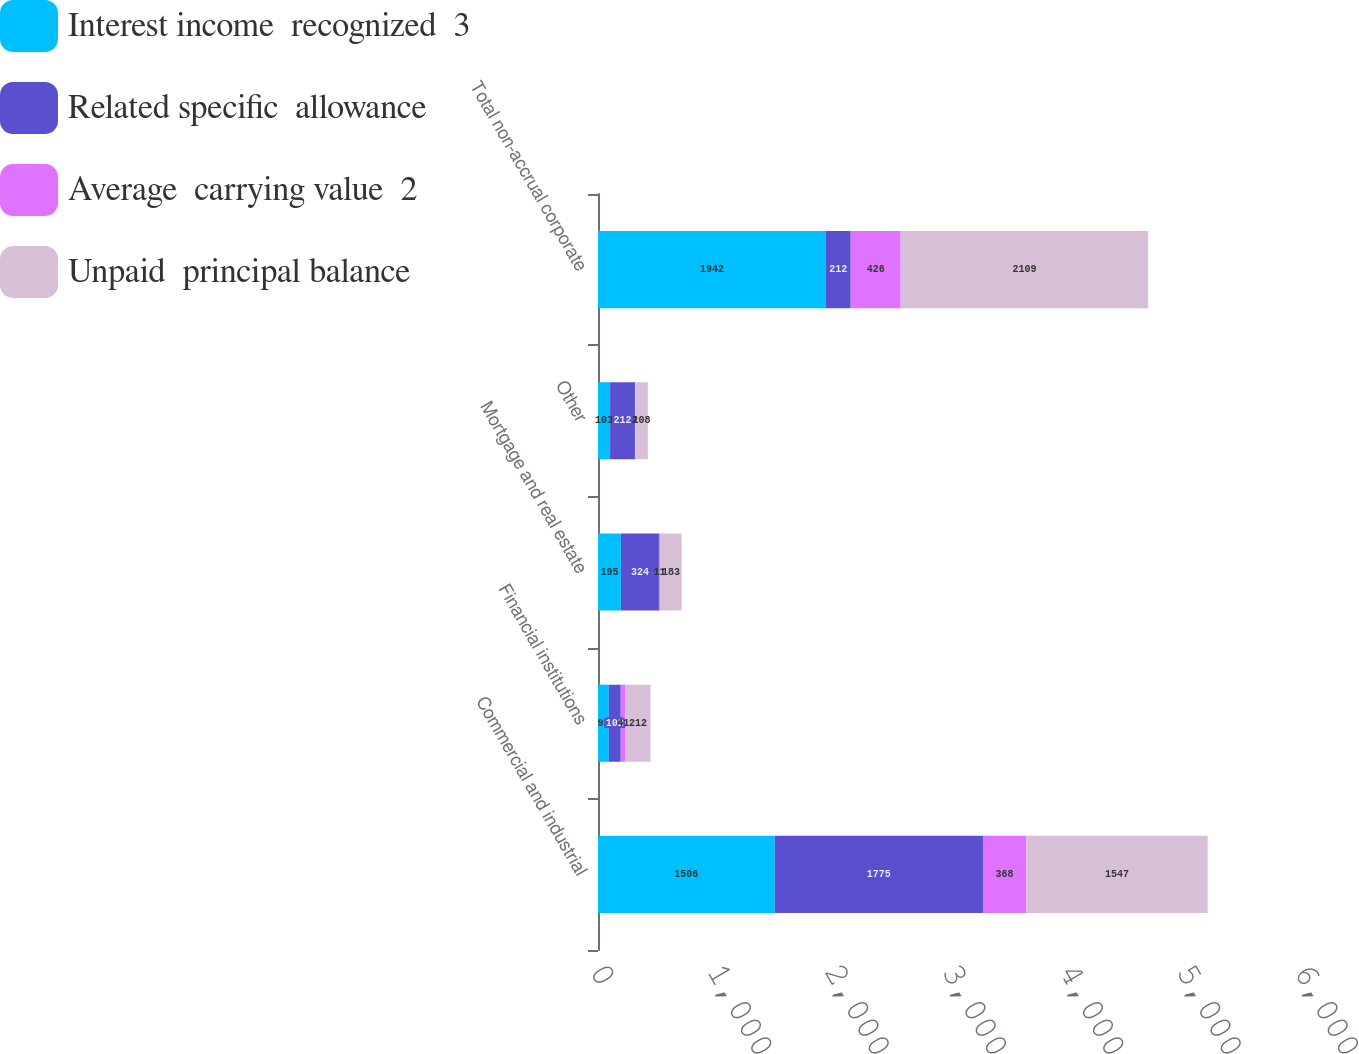Convert chart to OTSL. <chart><loc_0><loc_0><loc_500><loc_500><stacked_bar_chart><ecel><fcel>Commercial and industrial<fcel>Financial institutions<fcel>Mortgage and real estate<fcel>Other<fcel>Total non-accrual corporate<nl><fcel>Interest income  recognized  3<fcel>1506<fcel>92<fcel>195<fcel>103<fcel>1942<nl><fcel>Related specific  allowance<fcel>1775<fcel>102<fcel>324<fcel>212<fcel>212<nl><fcel>Average  carrying value  2<fcel>368<fcel>41<fcel>11<fcel>2<fcel>426<nl><fcel>Unpaid  principal balance<fcel>1547<fcel>212<fcel>183<fcel>108<fcel>2109<nl></chart> 